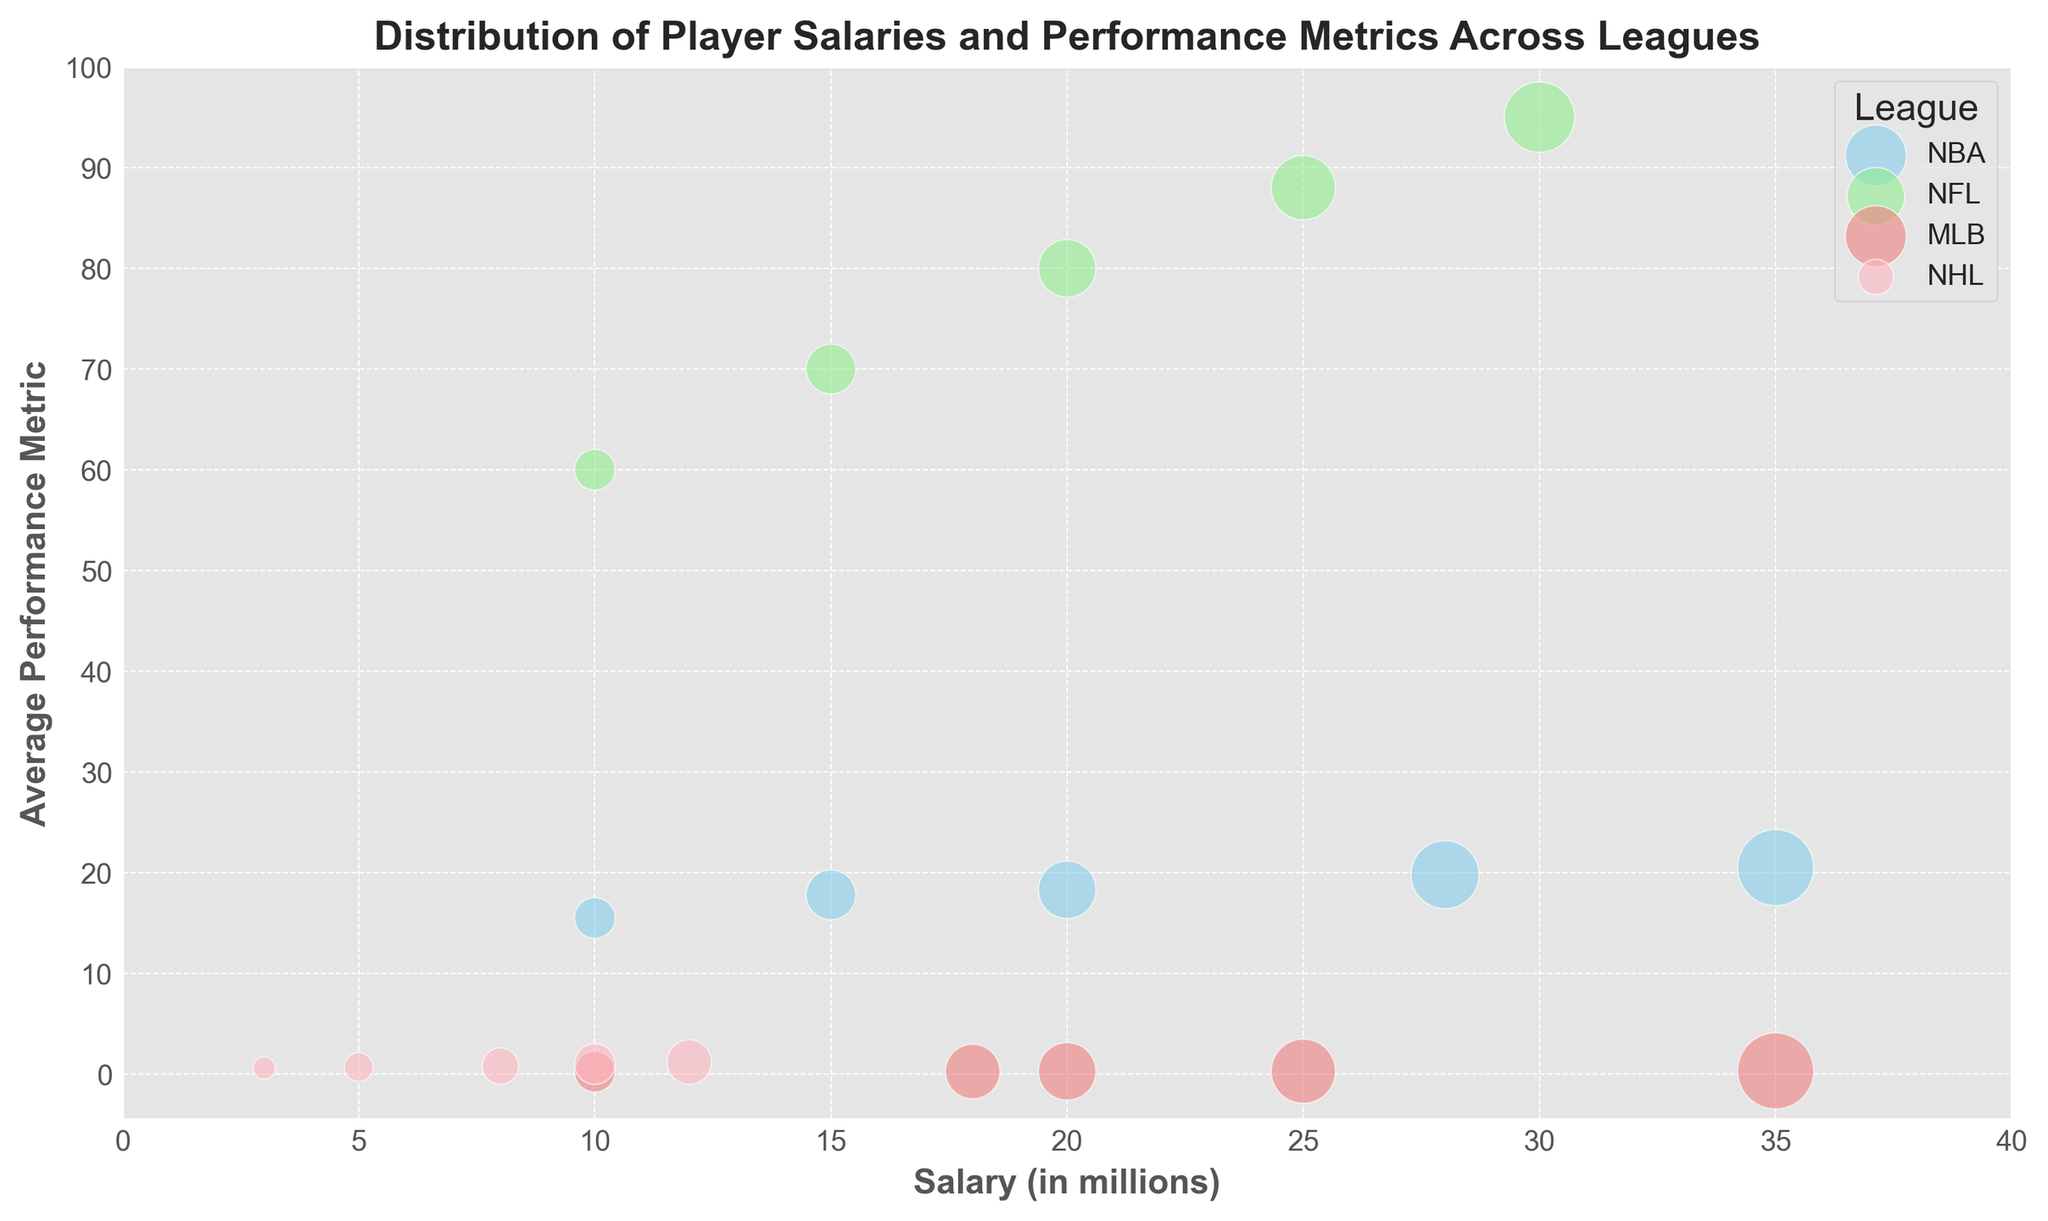How many NBA players have a salary greater than $20 million? From the figure, we can count the number of players in the NBA category (skyblue bubbles) that have a salary greater than $20 million on the x-axis. There are 2 such players: Player A ($35 million) and Player B ($28 million).
Answer: 2 Which league has the highest average performance metric among its top-paid players? To determine this, we locate the player with the highest salary within each league on the figure and then compare their performance metrics. For NBA, Player A has a performance metric of 20.5. For NFL, Player F has 95.0. For MLB, Player K has 0.320. For NHL, Player P has 1.2. Among these, NFL's Player F has the highest performance metric of 95.0.
Answer: NFL Which league's players have the smallest bubble sizes overall? Observing the chart, NHL players (lightpink bubbles) have generally smaller bubble sizes, indicating lower overall salaries and/or performance metrics compared to other leagues.
Answer: NHL Compare the average salary of the top 3 highest-paid players in the NBA and the NFL. Which one is higher? Calculate the sum and then the average of the top 3 salaries in each league by observing the x-axis values:
NBA: (35 + 28 + 20) / 3 = 83 / 3 = 27.67
NFL: (30 + 25 + 20) / 3 = 75 / 3 = 25
The average salary of the top 3 NBA players ($27.67 million) is higher than that of the NFL players ($25 million).
Answer: NBA What is the salary difference between the highest-paid player in MLB and the lowest-paid player in their respective league? Identify the highest and lowest salaries in the MLB section of the figure:
Highest: $35 million (Player K)
Lowest: $10 million (Player O)
Difference: $35 million - $10 million = $25 million
Answer: $25 million Do any NFL players have a performance metric that is less than 70? From the figure, among the NFL players (lightgreen bubbles), Player I and Player J both have performance metrics below 70 (70.0 and 60.0 respectively). Therefore, yes, some NFL players have performance metrics less than 70.
Answer: Yes What is the performance metric of the lowest-paid player in the NHL? Find the NHL player with the smallest bubble size corresponding to the lowest salary on the x-axis. That player is Player T with a salary of $3 million and a performance metric of 0.6.
Answer: 0.6 